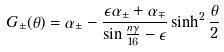Convert formula to latex. <formula><loc_0><loc_0><loc_500><loc_500>G _ { \pm } ( \theta ) = \alpha _ { \pm } - \frac { \epsilon \alpha _ { \pm } + \alpha _ { \mp } } { \sin { \frac { n \gamma } { 1 6 } } - \epsilon } \sinh ^ { 2 } \frac { \theta } { 2 }</formula> 